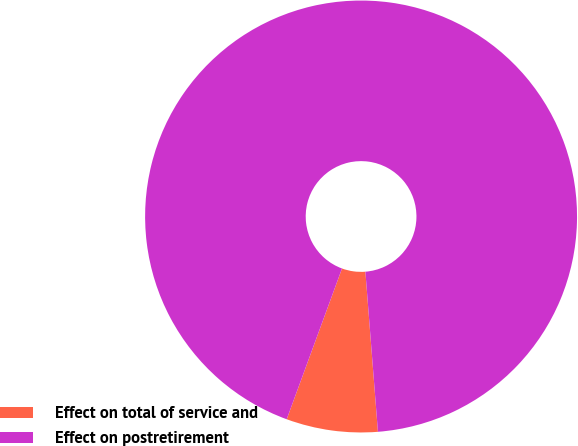Convert chart. <chart><loc_0><loc_0><loc_500><loc_500><pie_chart><fcel>Effect on total of service and<fcel>Effect on postretirement<nl><fcel>6.84%<fcel>93.16%<nl></chart> 